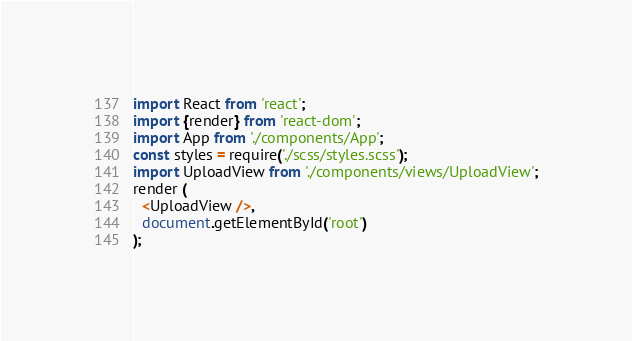Convert code to text. <code><loc_0><loc_0><loc_500><loc_500><_TypeScript_>import React from 'react';
import {render} from 'react-dom';
import App from './components/App';
const styles = require('./scss/styles.scss');
import UploadView from './components/views/UploadView';
render (
  <UploadView />,
  document.getElementById('root')
);</code> 